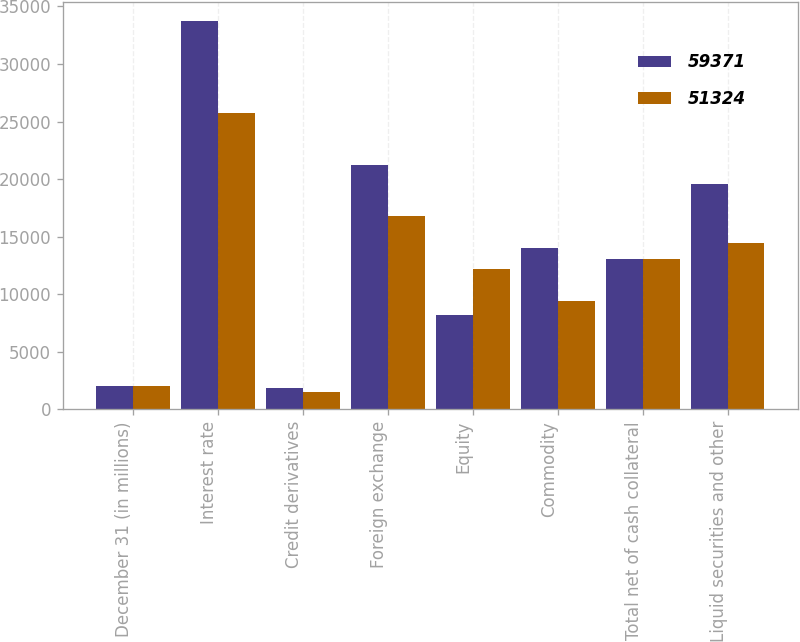Convert chart. <chart><loc_0><loc_0><loc_500><loc_500><stacked_bar_chart><ecel><fcel>December 31 (in millions)<fcel>Interest rate<fcel>Credit derivatives<fcel>Foreign exchange<fcel>Equity<fcel>Commodity<fcel>Total net of cash collateral<fcel>Liquid securities and other<nl><fcel>59371<fcel>2014<fcel>33725<fcel>1838<fcel>21253<fcel>8177<fcel>13982<fcel>13104.5<fcel>19604<nl><fcel>51324<fcel>2013<fcel>25782<fcel>1516<fcel>16790<fcel>12227<fcel>9444<fcel>13104.5<fcel>14435<nl></chart> 